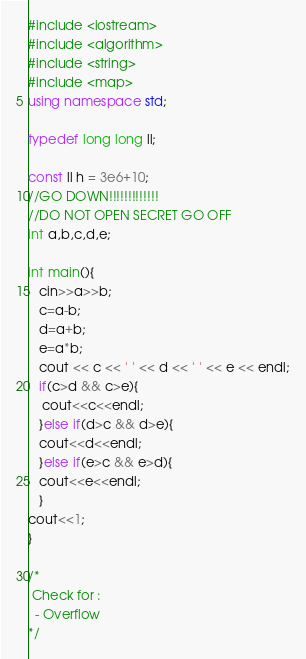<code> <loc_0><loc_0><loc_500><loc_500><_C++_>#include <iostream>
#include <algorithm>
#include <string>
#include <map>
using namespace std;

typedef long long ll;

const ll h = 3e6+10;
//GO DOWN!!!!!!!!!!!!!
//DO NOT OPEN SECRET GO OFF
int a,b,c,d,e;

int main(){
   cin>>a>>b;
   c=a-b;
   d=a+b;
   e=a*b;
   cout << c << ' ' << d << ' ' << e << endl;
   if(c>d && c>e){
    cout<<c<<endl;
   }else if(d>c && d>e){
   cout<<d<<endl;
   }else if(e>c && e>d){
   cout<<e<<endl;
   }
cout<<1;
}

/*
 Check for :
  - Overflow
*/
</code> 